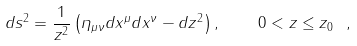<formula> <loc_0><loc_0><loc_500><loc_500>d s ^ { 2 } = \frac { 1 } { z ^ { 2 } } \left ( \eta _ { \mu \nu } d x ^ { \mu } d x ^ { \nu } - d z ^ { 2 } \right ) , { \quad } 0 < z \leq z _ { 0 } \ ,</formula> 